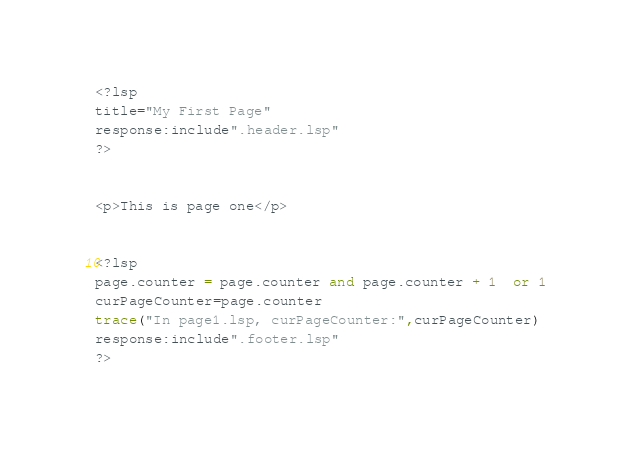Convert code to text. <code><loc_0><loc_0><loc_500><loc_500><_Lisp_><?lsp
title="My First Page"
response:include".header.lsp"
?>


<p>This is page one</p>


<?lsp
page.counter = page.counter and page.counter + 1  or 1
curPageCounter=page.counter
trace("In page1.lsp, curPageCounter:",curPageCounter)
response:include".footer.lsp"
?>
</code> 